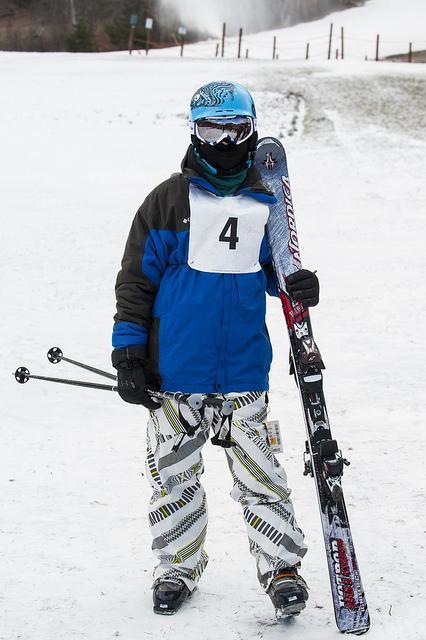How many skateboards do you see?
Give a very brief answer. 0. 